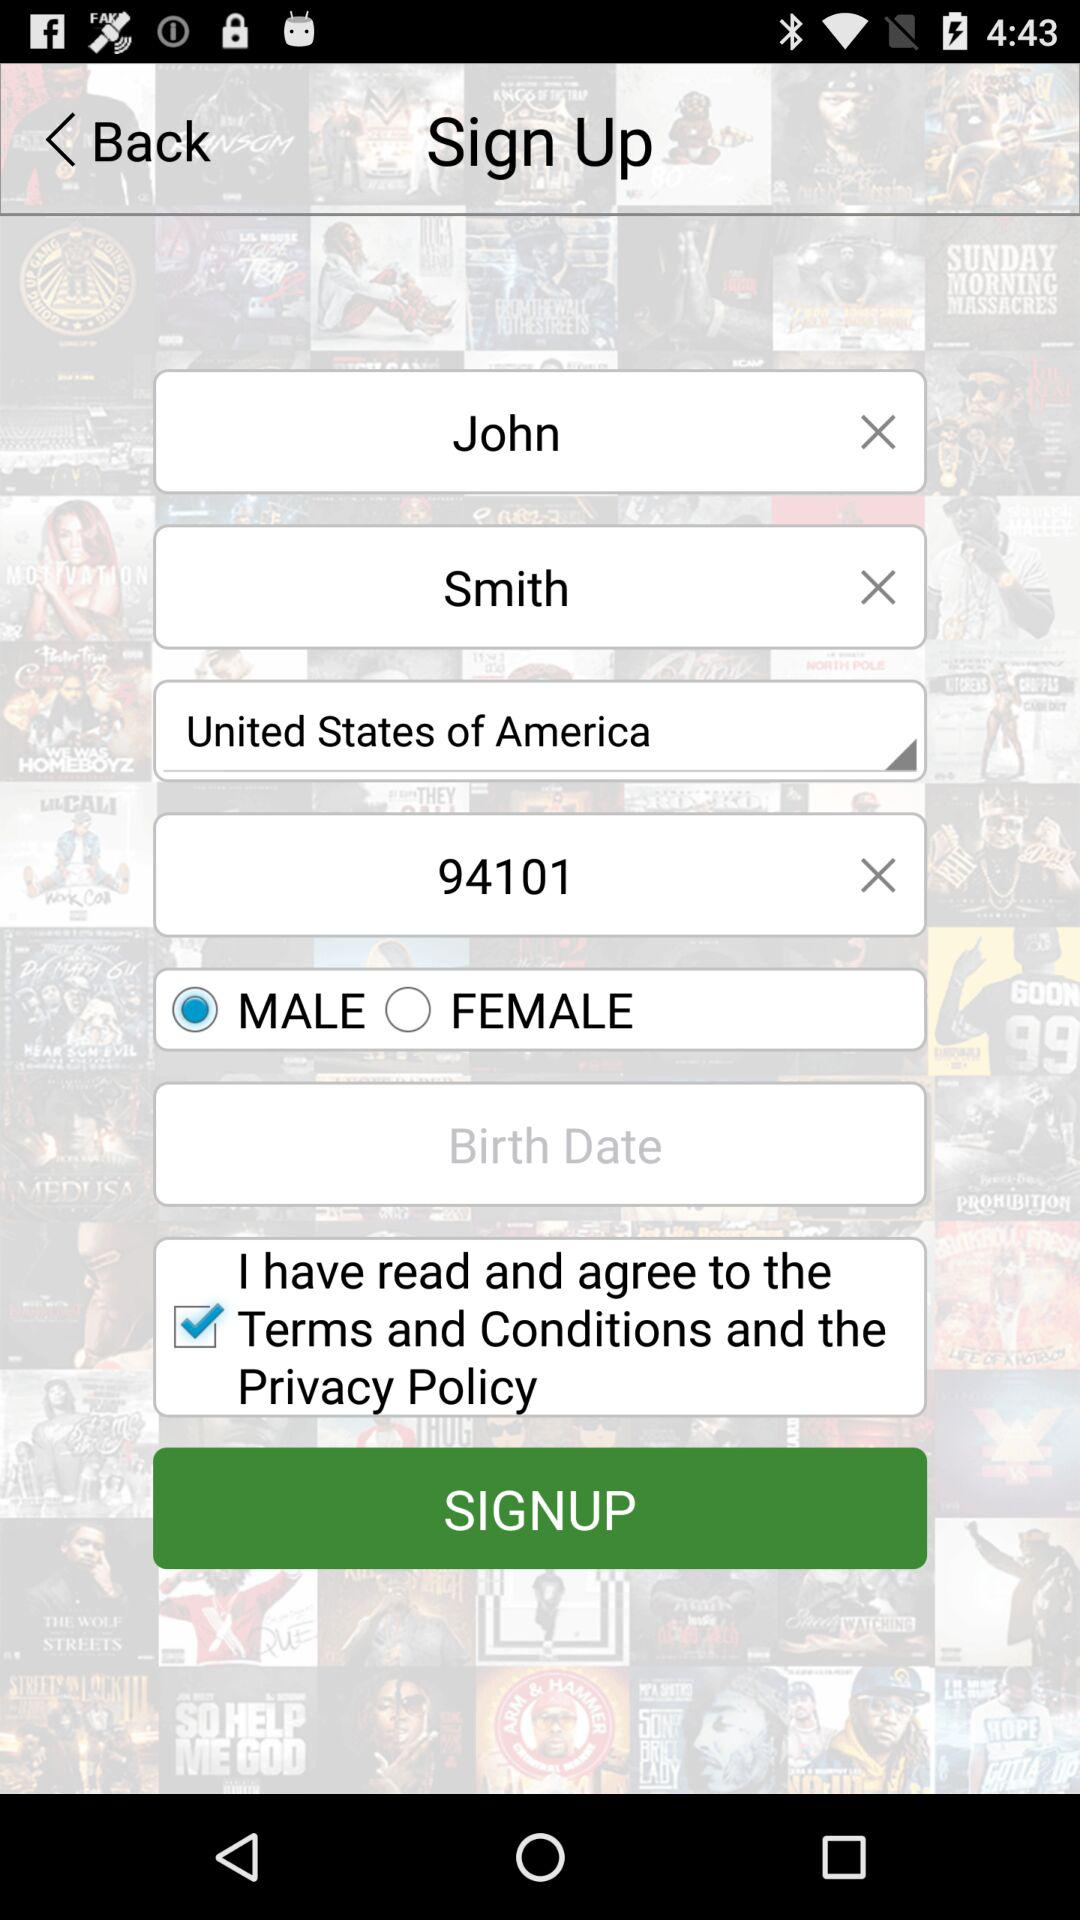Which gender is selected? The selected gender is male. 